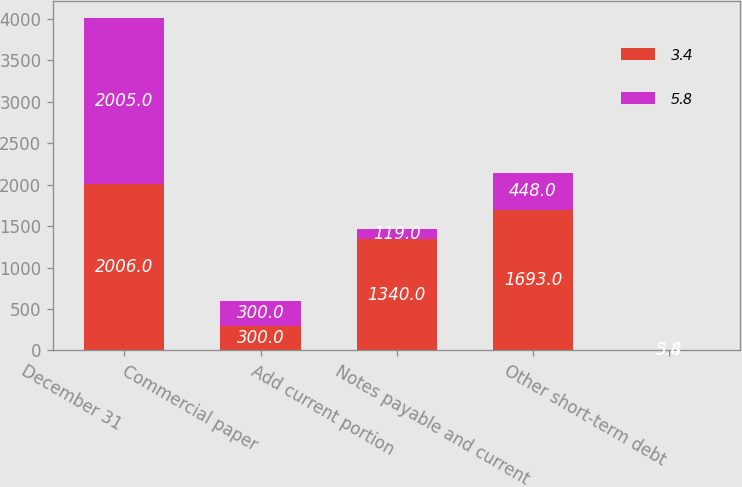Convert chart to OTSL. <chart><loc_0><loc_0><loc_500><loc_500><stacked_bar_chart><ecel><fcel>December 31<fcel>Commercial paper<fcel>Add current portion<fcel>Notes payable and current<fcel>Other short-term debt<nl><fcel>3.4<fcel>2006<fcel>300<fcel>1340<fcel>1693<fcel>5.8<nl><fcel>5.8<fcel>2005<fcel>300<fcel>119<fcel>448<fcel>3.4<nl></chart> 